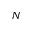<formula> <loc_0><loc_0><loc_500><loc_500>N</formula> 